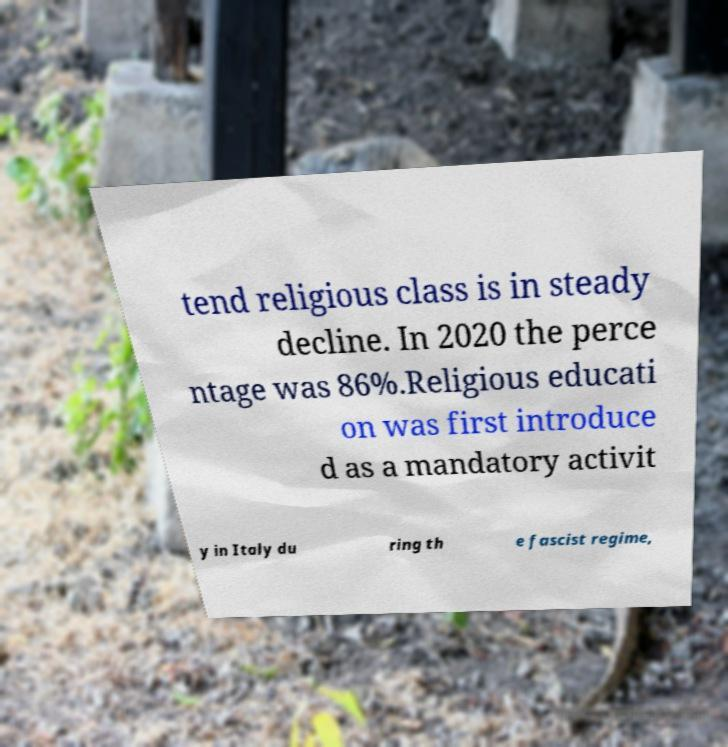Can you accurately transcribe the text from the provided image for me? tend religious class is in steady decline. In 2020 the perce ntage was 86%.Religious educati on was first introduce d as a mandatory activit y in Italy du ring th e fascist regime, 